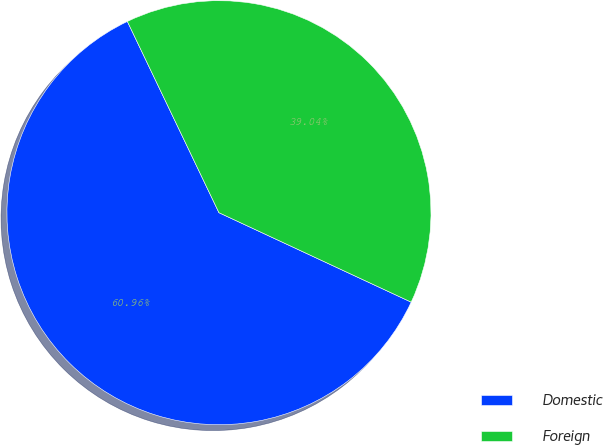<chart> <loc_0><loc_0><loc_500><loc_500><pie_chart><fcel>Domestic<fcel>Foreign<nl><fcel>60.96%<fcel>39.04%<nl></chart> 